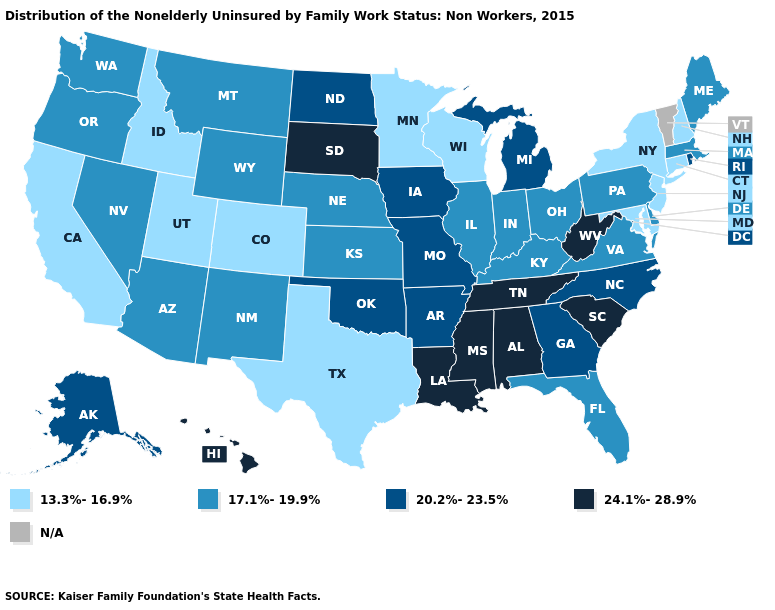Name the states that have a value in the range 13.3%-16.9%?
Answer briefly. California, Colorado, Connecticut, Idaho, Maryland, Minnesota, New Hampshire, New Jersey, New York, Texas, Utah, Wisconsin. Which states have the lowest value in the USA?
Give a very brief answer. California, Colorado, Connecticut, Idaho, Maryland, Minnesota, New Hampshire, New Jersey, New York, Texas, Utah, Wisconsin. What is the value of Kansas?
Keep it brief. 17.1%-19.9%. Among the states that border Arizona , does Nevada have the lowest value?
Answer briefly. No. What is the value of Kansas?
Write a very short answer. 17.1%-19.9%. Name the states that have a value in the range N/A?
Concise answer only. Vermont. Name the states that have a value in the range 13.3%-16.9%?
Write a very short answer. California, Colorado, Connecticut, Idaho, Maryland, Minnesota, New Hampshire, New Jersey, New York, Texas, Utah, Wisconsin. What is the lowest value in the South?
Concise answer only. 13.3%-16.9%. What is the lowest value in the USA?
Quick response, please. 13.3%-16.9%. What is the highest value in states that border Louisiana?
Give a very brief answer. 24.1%-28.9%. Name the states that have a value in the range N/A?
Concise answer only. Vermont. What is the value of Mississippi?
Short answer required. 24.1%-28.9%. Which states hav the highest value in the MidWest?
Short answer required. South Dakota. 